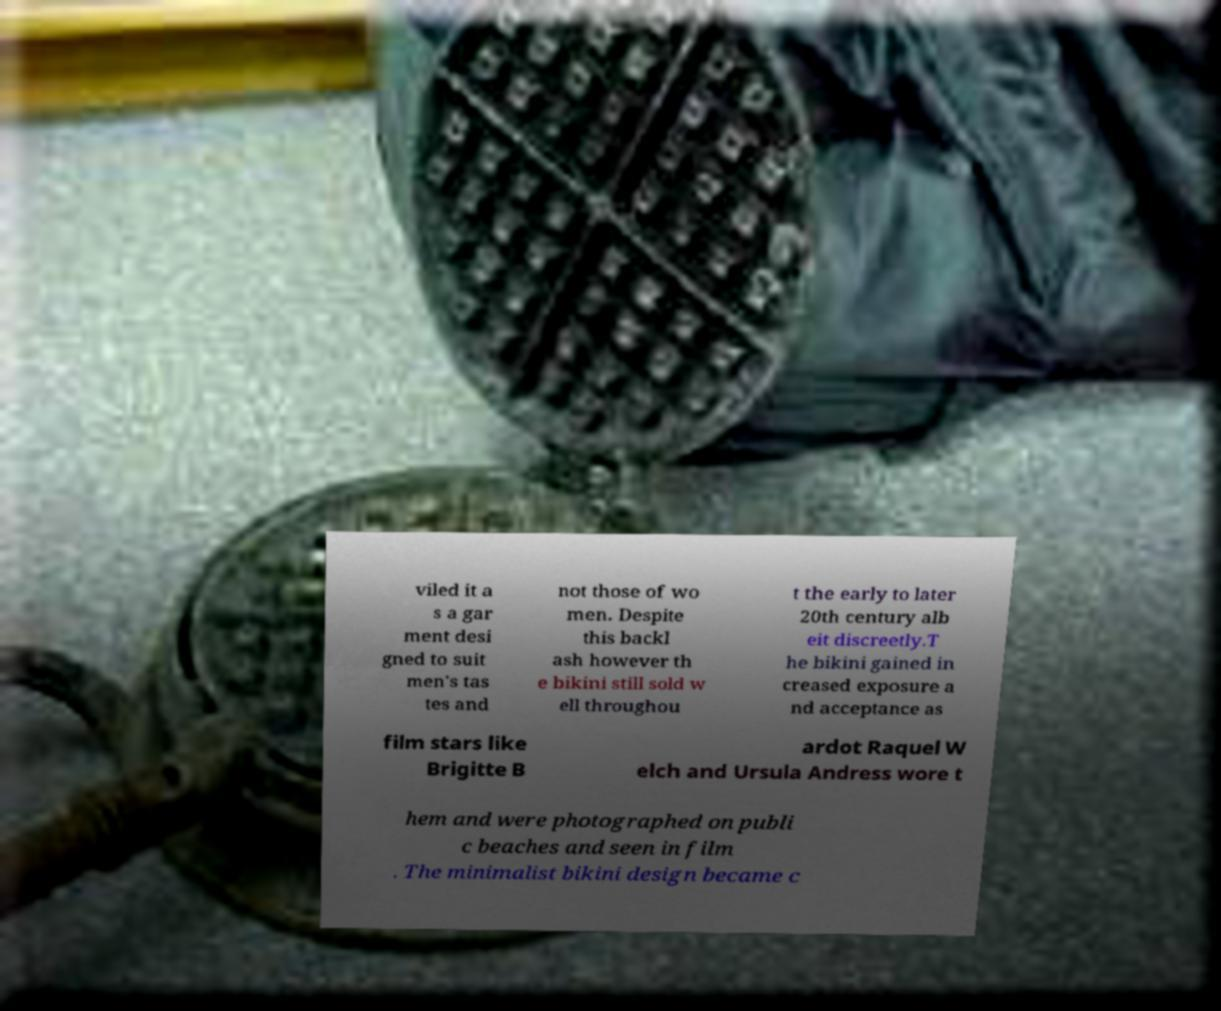Please identify and transcribe the text found in this image. viled it a s a gar ment desi gned to suit men's tas tes and not those of wo men. Despite this backl ash however th e bikini still sold w ell throughou t the early to later 20th century alb eit discreetly.T he bikini gained in creased exposure a nd acceptance as film stars like Brigitte B ardot Raquel W elch and Ursula Andress wore t hem and were photographed on publi c beaches and seen in film . The minimalist bikini design became c 